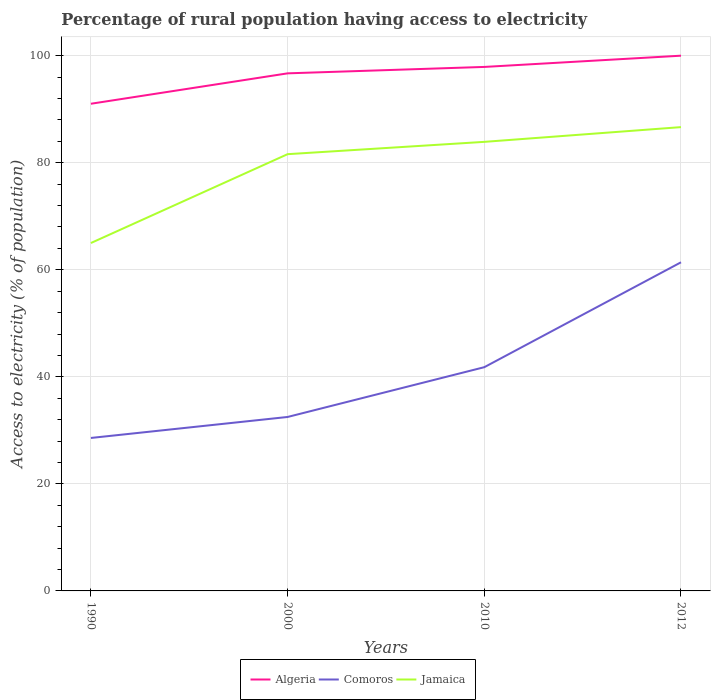Across all years, what is the maximum percentage of rural population having access to electricity in Jamaica?
Your answer should be compact. 65. In which year was the percentage of rural population having access to electricity in Algeria maximum?
Your answer should be very brief. 1990. What is the total percentage of rural population having access to electricity in Jamaica in the graph?
Offer a very short reply. -18.9. What is the difference between the highest and the second highest percentage of rural population having access to electricity in Comoros?
Provide a succinct answer. 32.82. How many years are there in the graph?
Your answer should be compact. 4. What is the difference between two consecutive major ticks on the Y-axis?
Your answer should be compact. 20. Are the values on the major ticks of Y-axis written in scientific E-notation?
Provide a short and direct response. No. Where does the legend appear in the graph?
Your response must be concise. Bottom center. How many legend labels are there?
Your response must be concise. 3. How are the legend labels stacked?
Your answer should be very brief. Horizontal. What is the title of the graph?
Offer a very short reply. Percentage of rural population having access to electricity. What is the label or title of the Y-axis?
Ensure brevity in your answer.  Access to electricity (% of population). What is the Access to electricity (% of population) of Algeria in 1990?
Offer a terse response. 91.02. What is the Access to electricity (% of population) in Comoros in 1990?
Provide a short and direct response. 28.58. What is the Access to electricity (% of population) of Algeria in 2000?
Make the answer very short. 96.7. What is the Access to electricity (% of population) of Comoros in 2000?
Keep it short and to the point. 32.5. What is the Access to electricity (% of population) in Jamaica in 2000?
Ensure brevity in your answer.  81.6. What is the Access to electricity (% of population) in Algeria in 2010?
Provide a short and direct response. 97.9. What is the Access to electricity (% of population) of Comoros in 2010?
Offer a very short reply. 41.8. What is the Access to electricity (% of population) in Jamaica in 2010?
Your response must be concise. 83.9. What is the Access to electricity (% of population) in Comoros in 2012?
Provide a succinct answer. 61.4. What is the Access to electricity (% of population) in Jamaica in 2012?
Your answer should be compact. 86.65. Across all years, what is the maximum Access to electricity (% of population) of Algeria?
Give a very brief answer. 100. Across all years, what is the maximum Access to electricity (% of population) of Comoros?
Your response must be concise. 61.4. Across all years, what is the maximum Access to electricity (% of population) of Jamaica?
Your answer should be compact. 86.65. Across all years, what is the minimum Access to electricity (% of population) of Algeria?
Your response must be concise. 91.02. Across all years, what is the minimum Access to electricity (% of population) in Comoros?
Your answer should be compact. 28.58. Across all years, what is the minimum Access to electricity (% of population) in Jamaica?
Your answer should be compact. 65. What is the total Access to electricity (% of population) in Algeria in the graph?
Your answer should be compact. 385.62. What is the total Access to electricity (% of population) of Comoros in the graph?
Your answer should be compact. 164.28. What is the total Access to electricity (% of population) of Jamaica in the graph?
Your response must be concise. 317.15. What is the difference between the Access to electricity (% of population) in Algeria in 1990 and that in 2000?
Your answer should be compact. -5.68. What is the difference between the Access to electricity (% of population) of Comoros in 1990 and that in 2000?
Ensure brevity in your answer.  -3.92. What is the difference between the Access to electricity (% of population) in Jamaica in 1990 and that in 2000?
Give a very brief answer. -16.6. What is the difference between the Access to electricity (% of population) of Algeria in 1990 and that in 2010?
Offer a terse response. -6.88. What is the difference between the Access to electricity (% of population) of Comoros in 1990 and that in 2010?
Your answer should be very brief. -13.22. What is the difference between the Access to electricity (% of population) in Jamaica in 1990 and that in 2010?
Keep it short and to the point. -18.9. What is the difference between the Access to electricity (% of population) in Algeria in 1990 and that in 2012?
Offer a very short reply. -8.98. What is the difference between the Access to electricity (% of population) in Comoros in 1990 and that in 2012?
Make the answer very short. -32.82. What is the difference between the Access to electricity (% of population) in Jamaica in 1990 and that in 2012?
Give a very brief answer. -21.65. What is the difference between the Access to electricity (% of population) in Comoros in 2000 and that in 2010?
Your answer should be compact. -9.3. What is the difference between the Access to electricity (% of population) of Algeria in 2000 and that in 2012?
Your answer should be compact. -3.3. What is the difference between the Access to electricity (% of population) of Comoros in 2000 and that in 2012?
Provide a succinct answer. -28.9. What is the difference between the Access to electricity (% of population) of Jamaica in 2000 and that in 2012?
Offer a very short reply. -5.05. What is the difference between the Access to electricity (% of population) in Comoros in 2010 and that in 2012?
Provide a succinct answer. -19.6. What is the difference between the Access to electricity (% of population) of Jamaica in 2010 and that in 2012?
Provide a short and direct response. -2.75. What is the difference between the Access to electricity (% of population) in Algeria in 1990 and the Access to electricity (% of population) in Comoros in 2000?
Provide a succinct answer. 58.52. What is the difference between the Access to electricity (% of population) in Algeria in 1990 and the Access to electricity (% of population) in Jamaica in 2000?
Make the answer very short. 9.42. What is the difference between the Access to electricity (% of population) of Comoros in 1990 and the Access to electricity (% of population) of Jamaica in 2000?
Offer a terse response. -53.02. What is the difference between the Access to electricity (% of population) of Algeria in 1990 and the Access to electricity (% of population) of Comoros in 2010?
Give a very brief answer. 49.22. What is the difference between the Access to electricity (% of population) in Algeria in 1990 and the Access to electricity (% of population) in Jamaica in 2010?
Offer a very short reply. 7.12. What is the difference between the Access to electricity (% of population) of Comoros in 1990 and the Access to electricity (% of population) of Jamaica in 2010?
Ensure brevity in your answer.  -55.32. What is the difference between the Access to electricity (% of population) of Algeria in 1990 and the Access to electricity (% of population) of Comoros in 2012?
Give a very brief answer. 29.62. What is the difference between the Access to electricity (% of population) in Algeria in 1990 and the Access to electricity (% of population) in Jamaica in 2012?
Offer a terse response. 4.37. What is the difference between the Access to electricity (% of population) of Comoros in 1990 and the Access to electricity (% of population) of Jamaica in 2012?
Ensure brevity in your answer.  -58.08. What is the difference between the Access to electricity (% of population) of Algeria in 2000 and the Access to electricity (% of population) of Comoros in 2010?
Offer a very short reply. 54.9. What is the difference between the Access to electricity (% of population) of Comoros in 2000 and the Access to electricity (% of population) of Jamaica in 2010?
Keep it short and to the point. -51.4. What is the difference between the Access to electricity (% of population) in Algeria in 2000 and the Access to electricity (% of population) in Comoros in 2012?
Offer a terse response. 35.3. What is the difference between the Access to electricity (% of population) of Algeria in 2000 and the Access to electricity (% of population) of Jamaica in 2012?
Ensure brevity in your answer.  10.05. What is the difference between the Access to electricity (% of population) in Comoros in 2000 and the Access to electricity (% of population) in Jamaica in 2012?
Your answer should be compact. -54.15. What is the difference between the Access to electricity (% of population) of Algeria in 2010 and the Access to electricity (% of population) of Comoros in 2012?
Your answer should be compact. 36.5. What is the difference between the Access to electricity (% of population) in Algeria in 2010 and the Access to electricity (% of population) in Jamaica in 2012?
Ensure brevity in your answer.  11.25. What is the difference between the Access to electricity (% of population) in Comoros in 2010 and the Access to electricity (% of population) in Jamaica in 2012?
Make the answer very short. -44.85. What is the average Access to electricity (% of population) of Algeria per year?
Provide a short and direct response. 96.4. What is the average Access to electricity (% of population) of Comoros per year?
Keep it short and to the point. 41.07. What is the average Access to electricity (% of population) of Jamaica per year?
Give a very brief answer. 79.29. In the year 1990, what is the difference between the Access to electricity (% of population) in Algeria and Access to electricity (% of population) in Comoros?
Your response must be concise. 62.44. In the year 1990, what is the difference between the Access to electricity (% of population) in Algeria and Access to electricity (% of population) in Jamaica?
Provide a succinct answer. 26.02. In the year 1990, what is the difference between the Access to electricity (% of population) of Comoros and Access to electricity (% of population) of Jamaica?
Ensure brevity in your answer.  -36.42. In the year 2000, what is the difference between the Access to electricity (% of population) in Algeria and Access to electricity (% of population) in Comoros?
Provide a succinct answer. 64.2. In the year 2000, what is the difference between the Access to electricity (% of population) of Algeria and Access to electricity (% of population) of Jamaica?
Keep it short and to the point. 15.1. In the year 2000, what is the difference between the Access to electricity (% of population) of Comoros and Access to electricity (% of population) of Jamaica?
Your response must be concise. -49.1. In the year 2010, what is the difference between the Access to electricity (% of population) in Algeria and Access to electricity (% of population) in Comoros?
Offer a terse response. 56.1. In the year 2010, what is the difference between the Access to electricity (% of population) of Algeria and Access to electricity (% of population) of Jamaica?
Your answer should be very brief. 14. In the year 2010, what is the difference between the Access to electricity (% of population) of Comoros and Access to electricity (% of population) of Jamaica?
Provide a succinct answer. -42.1. In the year 2012, what is the difference between the Access to electricity (% of population) of Algeria and Access to electricity (% of population) of Comoros?
Keep it short and to the point. 38.6. In the year 2012, what is the difference between the Access to electricity (% of population) of Algeria and Access to electricity (% of population) of Jamaica?
Ensure brevity in your answer.  13.35. In the year 2012, what is the difference between the Access to electricity (% of population) of Comoros and Access to electricity (% of population) of Jamaica?
Offer a very short reply. -25.25. What is the ratio of the Access to electricity (% of population) in Algeria in 1990 to that in 2000?
Your response must be concise. 0.94. What is the ratio of the Access to electricity (% of population) of Comoros in 1990 to that in 2000?
Give a very brief answer. 0.88. What is the ratio of the Access to electricity (% of population) in Jamaica in 1990 to that in 2000?
Your response must be concise. 0.8. What is the ratio of the Access to electricity (% of population) in Algeria in 1990 to that in 2010?
Offer a very short reply. 0.93. What is the ratio of the Access to electricity (% of population) in Comoros in 1990 to that in 2010?
Your response must be concise. 0.68. What is the ratio of the Access to electricity (% of population) in Jamaica in 1990 to that in 2010?
Ensure brevity in your answer.  0.77. What is the ratio of the Access to electricity (% of population) in Algeria in 1990 to that in 2012?
Ensure brevity in your answer.  0.91. What is the ratio of the Access to electricity (% of population) of Comoros in 1990 to that in 2012?
Your answer should be very brief. 0.47. What is the ratio of the Access to electricity (% of population) of Jamaica in 1990 to that in 2012?
Offer a terse response. 0.75. What is the ratio of the Access to electricity (% of population) of Comoros in 2000 to that in 2010?
Provide a succinct answer. 0.78. What is the ratio of the Access to electricity (% of population) in Jamaica in 2000 to that in 2010?
Your response must be concise. 0.97. What is the ratio of the Access to electricity (% of population) in Comoros in 2000 to that in 2012?
Make the answer very short. 0.53. What is the ratio of the Access to electricity (% of population) of Jamaica in 2000 to that in 2012?
Give a very brief answer. 0.94. What is the ratio of the Access to electricity (% of population) of Comoros in 2010 to that in 2012?
Keep it short and to the point. 0.68. What is the ratio of the Access to electricity (% of population) in Jamaica in 2010 to that in 2012?
Offer a very short reply. 0.97. What is the difference between the highest and the second highest Access to electricity (% of population) in Algeria?
Provide a succinct answer. 2.1. What is the difference between the highest and the second highest Access to electricity (% of population) in Comoros?
Make the answer very short. 19.6. What is the difference between the highest and the second highest Access to electricity (% of population) in Jamaica?
Keep it short and to the point. 2.75. What is the difference between the highest and the lowest Access to electricity (% of population) of Algeria?
Make the answer very short. 8.98. What is the difference between the highest and the lowest Access to electricity (% of population) of Comoros?
Offer a very short reply. 32.82. What is the difference between the highest and the lowest Access to electricity (% of population) in Jamaica?
Your answer should be compact. 21.65. 